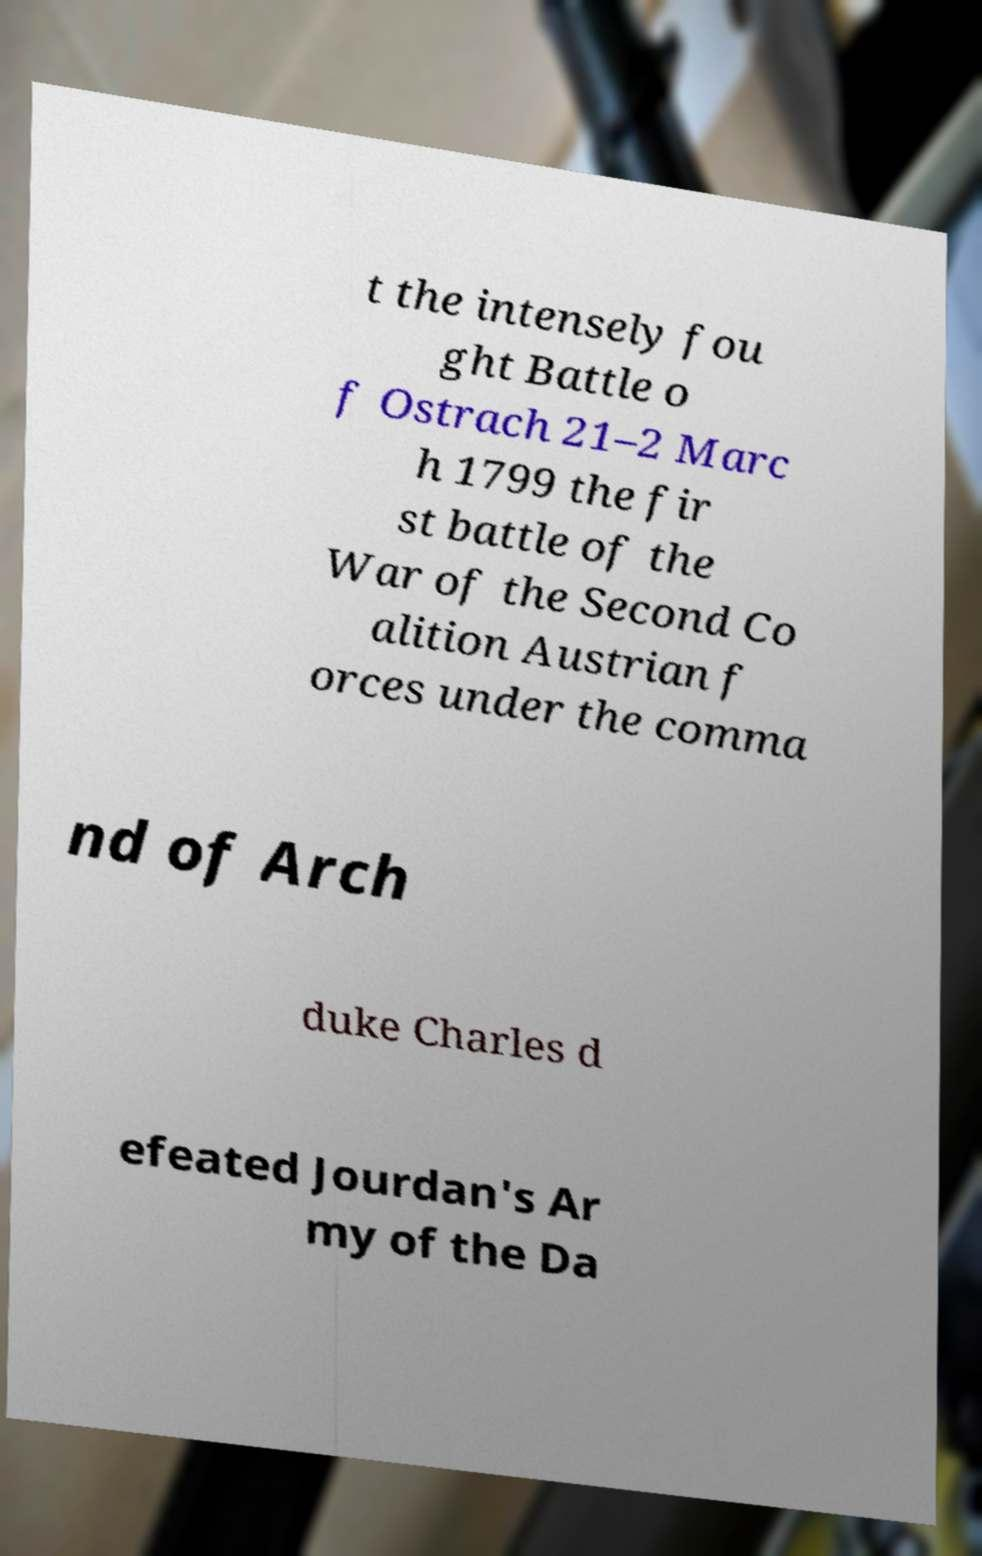There's text embedded in this image that I need extracted. Can you transcribe it verbatim? t the intensely fou ght Battle o f Ostrach 21–2 Marc h 1799 the fir st battle of the War of the Second Co alition Austrian f orces under the comma nd of Arch duke Charles d efeated Jourdan's Ar my of the Da 